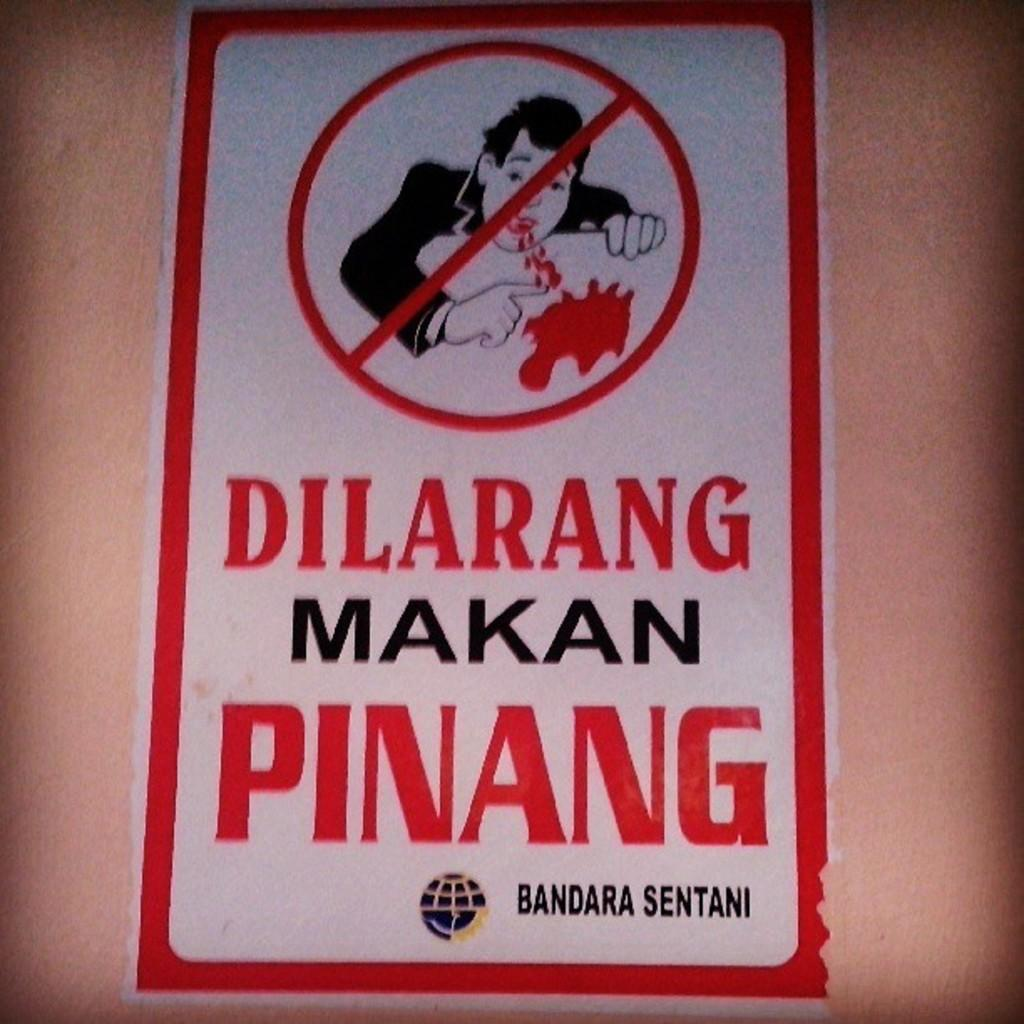Provide a one-sentence caption for the provided image. Dilarang Makan Pinang is written on this warning sign. 